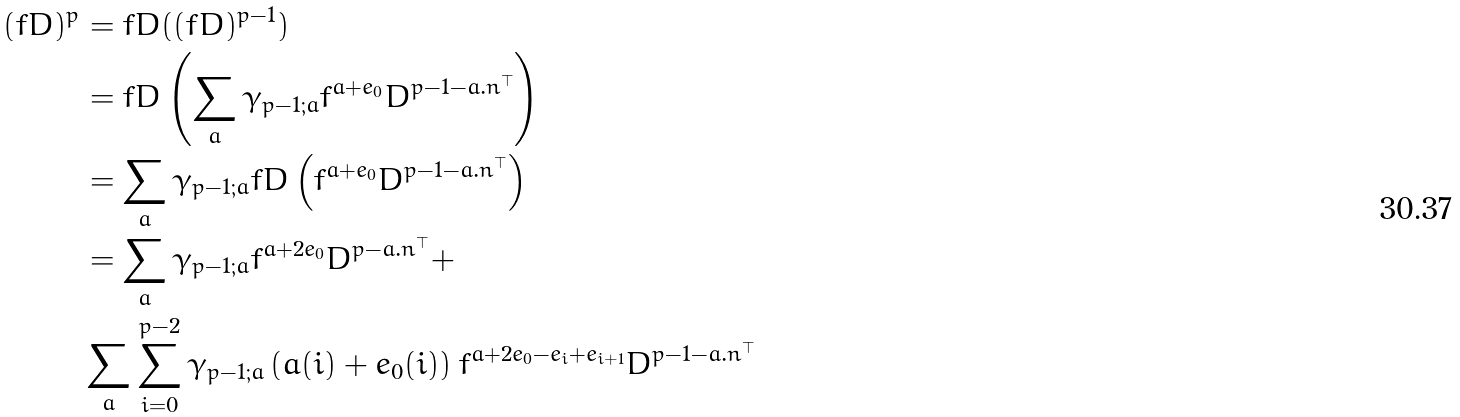<formula> <loc_0><loc_0><loc_500><loc_500>( f D ) ^ { p } & = f D ( ( f D ) ^ { p - 1 } ) \\ & = f D \left ( \sum _ { a } \gamma _ { p - 1 ; { a } } f ^ { { a } + { e _ { 0 } } } D ^ { p - 1 - { a } . { n } ^ { \top } } \right ) \\ & = \sum _ { a } \gamma _ { p - 1 ; { a } } f D \left ( f ^ { { a } + { e _ { 0 } } } D ^ { p - 1 - { a } . { n } ^ { \top } } \right ) \\ & = \sum _ { a } \gamma _ { p - 1 ; { a } } f ^ { { a } + 2 { e _ { 0 } } } D ^ { p - { a } . { n } ^ { \top } } + \\ & \sum _ { a } \sum _ { i = 0 } ^ { p - 2 } \gamma _ { p - 1 ; { a } } \left ( { a } ( i ) + { e _ { 0 } } ( i ) \right ) f ^ { { a } + 2 { e _ { 0 } } - { e _ { i } } + { e _ { i + 1 } } } D ^ { p - 1 - { a } . { n } ^ { \top } }</formula> 